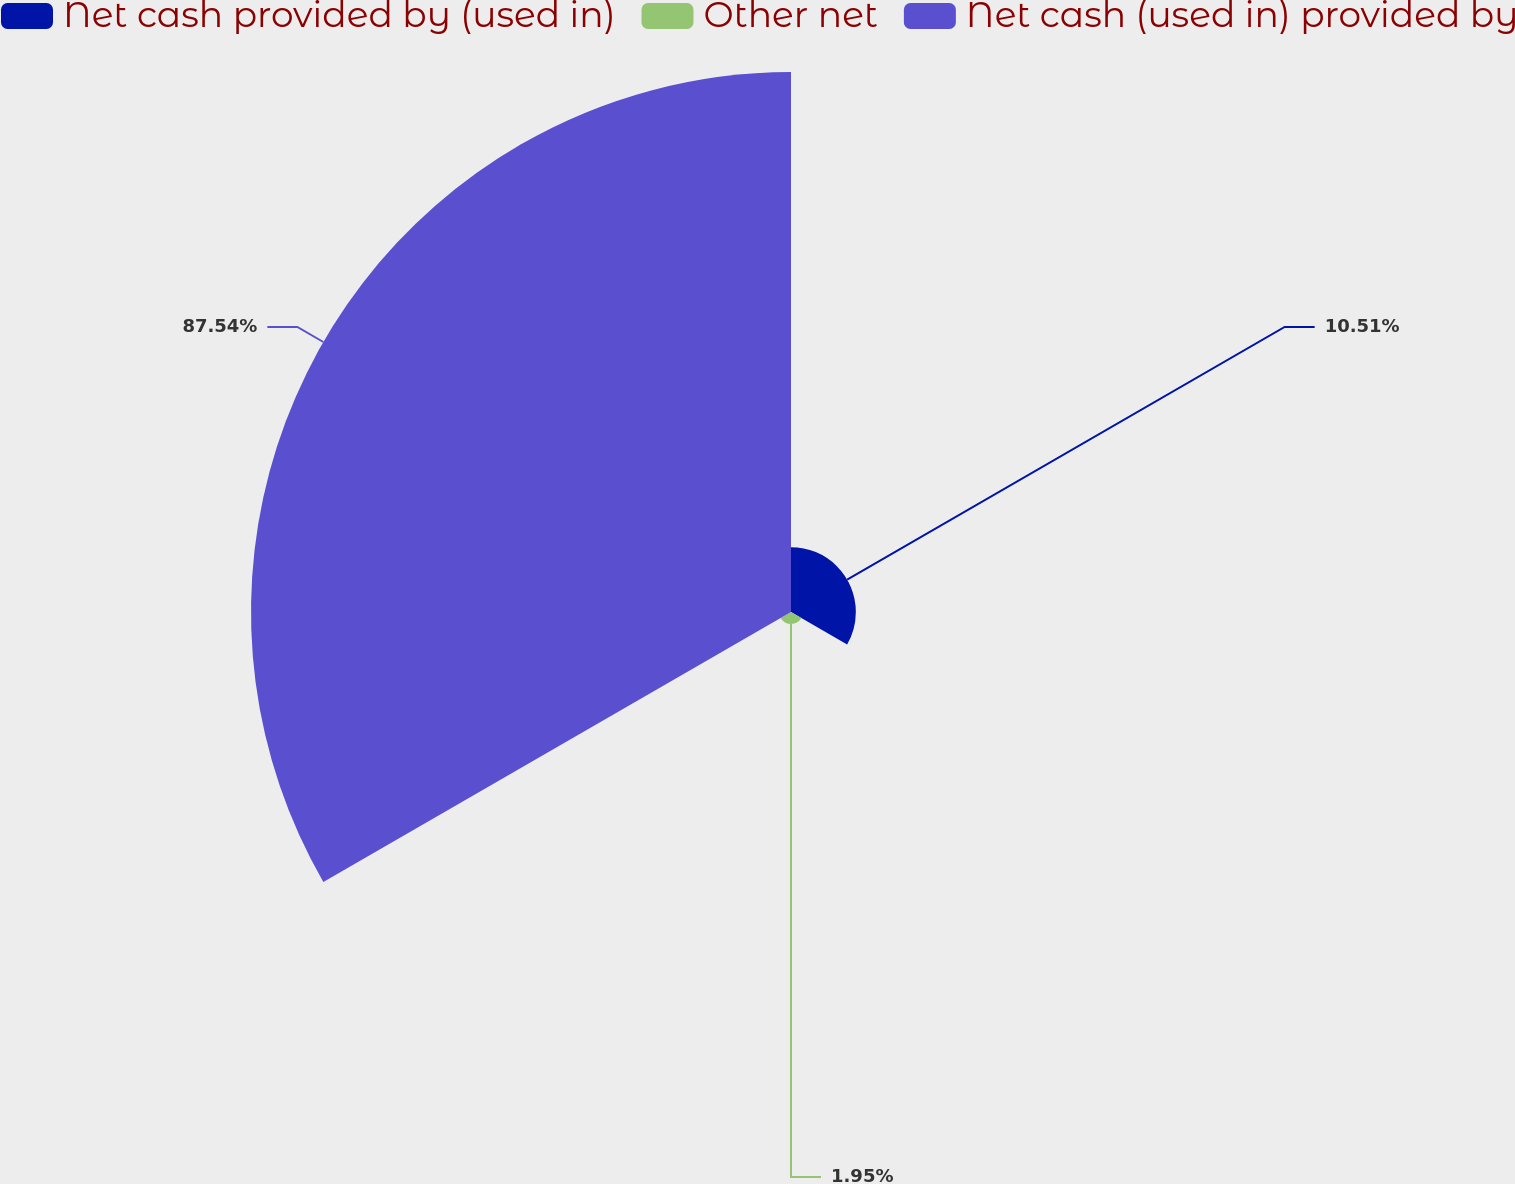Convert chart. <chart><loc_0><loc_0><loc_500><loc_500><pie_chart><fcel>Net cash provided by (used in)<fcel>Other net<fcel>Net cash (used in) provided by<nl><fcel>10.51%<fcel>1.95%<fcel>87.53%<nl></chart> 